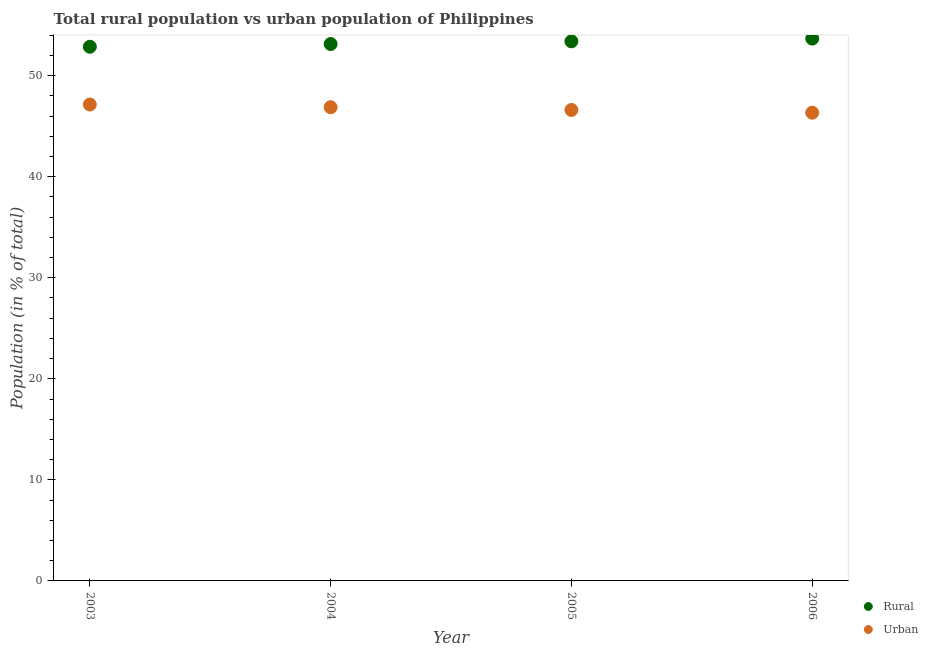How many different coloured dotlines are there?
Keep it short and to the point. 2. What is the urban population in 2004?
Provide a succinct answer. 46.87. Across all years, what is the maximum rural population?
Provide a short and direct response. 53.67. Across all years, what is the minimum urban population?
Keep it short and to the point. 46.33. What is the total rural population in the graph?
Your response must be concise. 213.05. What is the difference between the rural population in 2004 and that in 2005?
Provide a short and direct response. -0.27. What is the difference between the urban population in 2003 and the rural population in 2004?
Offer a very short reply. -5.98. What is the average urban population per year?
Offer a very short reply. 46.74. In the year 2006, what is the difference between the rural population and urban population?
Your answer should be very brief. 7.33. What is the ratio of the urban population in 2005 to that in 2006?
Your answer should be very brief. 1.01. Is the rural population in 2003 less than that in 2005?
Keep it short and to the point. Yes. Is the difference between the rural population in 2003 and 2006 greater than the difference between the urban population in 2003 and 2006?
Your response must be concise. No. What is the difference between the highest and the second highest urban population?
Provide a succinct answer. 0.27. What is the difference between the highest and the lowest rural population?
Keep it short and to the point. 0.81. Does the urban population monotonically increase over the years?
Make the answer very short. No. Is the urban population strictly greater than the rural population over the years?
Your answer should be very brief. No. Are the values on the major ticks of Y-axis written in scientific E-notation?
Offer a very short reply. No. Does the graph contain grids?
Ensure brevity in your answer.  No. How many legend labels are there?
Your answer should be very brief. 2. How are the legend labels stacked?
Ensure brevity in your answer.  Vertical. What is the title of the graph?
Keep it short and to the point. Total rural population vs urban population of Philippines. What is the label or title of the Y-axis?
Make the answer very short. Population (in % of total). What is the Population (in % of total) in Rural in 2003?
Offer a terse response. 52.86. What is the Population (in % of total) in Urban in 2003?
Offer a terse response. 47.14. What is the Population (in % of total) of Rural in 2004?
Make the answer very short. 53.13. What is the Population (in % of total) of Urban in 2004?
Your answer should be compact. 46.87. What is the Population (in % of total) in Rural in 2005?
Ensure brevity in your answer.  53.4. What is the Population (in % of total) in Urban in 2005?
Your answer should be very brief. 46.6. What is the Population (in % of total) in Rural in 2006?
Ensure brevity in your answer.  53.67. What is the Population (in % of total) in Urban in 2006?
Provide a succinct answer. 46.33. Across all years, what is the maximum Population (in % of total) of Rural?
Make the answer very short. 53.67. Across all years, what is the maximum Population (in % of total) in Urban?
Give a very brief answer. 47.14. Across all years, what is the minimum Population (in % of total) in Rural?
Ensure brevity in your answer.  52.86. Across all years, what is the minimum Population (in % of total) of Urban?
Provide a succinct answer. 46.33. What is the total Population (in % of total) of Rural in the graph?
Offer a very short reply. 213.05. What is the total Population (in % of total) of Urban in the graph?
Provide a succinct answer. 186.95. What is the difference between the Population (in % of total) in Rural in 2003 and that in 2004?
Your answer should be compact. -0.27. What is the difference between the Population (in % of total) in Urban in 2003 and that in 2004?
Provide a short and direct response. 0.27. What is the difference between the Population (in % of total) of Rural in 2003 and that in 2005?
Your answer should be very brief. -0.54. What is the difference between the Population (in % of total) in Urban in 2003 and that in 2005?
Keep it short and to the point. 0.54. What is the difference between the Population (in % of total) in Rural in 2003 and that in 2006?
Your answer should be compact. -0.81. What is the difference between the Population (in % of total) of Urban in 2003 and that in 2006?
Make the answer very short. 0.81. What is the difference between the Population (in % of total) of Rural in 2004 and that in 2005?
Offer a very short reply. -0.27. What is the difference between the Population (in % of total) of Urban in 2004 and that in 2005?
Your response must be concise. 0.27. What is the difference between the Population (in % of total) of Rural in 2004 and that in 2006?
Keep it short and to the point. -0.54. What is the difference between the Population (in % of total) in Urban in 2004 and that in 2006?
Give a very brief answer. 0.54. What is the difference between the Population (in % of total) in Rural in 2005 and that in 2006?
Your response must be concise. -0.27. What is the difference between the Population (in % of total) in Urban in 2005 and that in 2006?
Ensure brevity in your answer.  0.27. What is the difference between the Population (in % of total) of Rural in 2003 and the Population (in % of total) of Urban in 2004?
Offer a terse response. 5.99. What is the difference between the Population (in % of total) in Rural in 2003 and the Population (in % of total) in Urban in 2005?
Provide a succinct answer. 6.25. What is the difference between the Population (in % of total) in Rural in 2003 and the Population (in % of total) in Urban in 2006?
Your answer should be very brief. 6.52. What is the difference between the Population (in % of total) of Rural in 2004 and the Population (in % of total) of Urban in 2005?
Keep it short and to the point. 6.53. What is the difference between the Population (in % of total) in Rural in 2004 and the Population (in % of total) in Urban in 2006?
Keep it short and to the point. 6.79. What is the difference between the Population (in % of total) of Rural in 2005 and the Population (in % of total) of Urban in 2006?
Your answer should be very brief. 7.06. What is the average Population (in % of total) of Rural per year?
Give a very brief answer. 53.26. What is the average Population (in % of total) of Urban per year?
Keep it short and to the point. 46.74. In the year 2003, what is the difference between the Population (in % of total) of Rural and Population (in % of total) of Urban?
Provide a succinct answer. 5.71. In the year 2004, what is the difference between the Population (in % of total) in Rural and Population (in % of total) in Urban?
Your answer should be very brief. 6.26. In the year 2005, what is the difference between the Population (in % of total) of Rural and Population (in % of total) of Urban?
Provide a short and direct response. 6.79. In the year 2006, what is the difference between the Population (in % of total) of Rural and Population (in % of total) of Urban?
Your answer should be very brief. 7.33. What is the ratio of the Population (in % of total) of Urban in 2003 to that in 2004?
Your answer should be very brief. 1.01. What is the ratio of the Population (in % of total) of Urban in 2003 to that in 2005?
Offer a very short reply. 1.01. What is the ratio of the Population (in % of total) in Rural in 2003 to that in 2006?
Your answer should be compact. 0.98. What is the ratio of the Population (in % of total) in Urban in 2003 to that in 2006?
Provide a succinct answer. 1.02. What is the ratio of the Population (in % of total) in Rural in 2004 to that in 2006?
Offer a terse response. 0.99. What is the ratio of the Population (in % of total) in Urban in 2004 to that in 2006?
Ensure brevity in your answer.  1.01. What is the difference between the highest and the second highest Population (in % of total) of Rural?
Your answer should be very brief. 0.27. What is the difference between the highest and the second highest Population (in % of total) in Urban?
Ensure brevity in your answer.  0.27. What is the difference between the highest and the lowest Population (in % of total) of Rural?
Give a very brief answer. 0.81. What is the difference between the highest and the lowest Population (in % of total) of Urban?
Your answer should be compact. 0.81. 